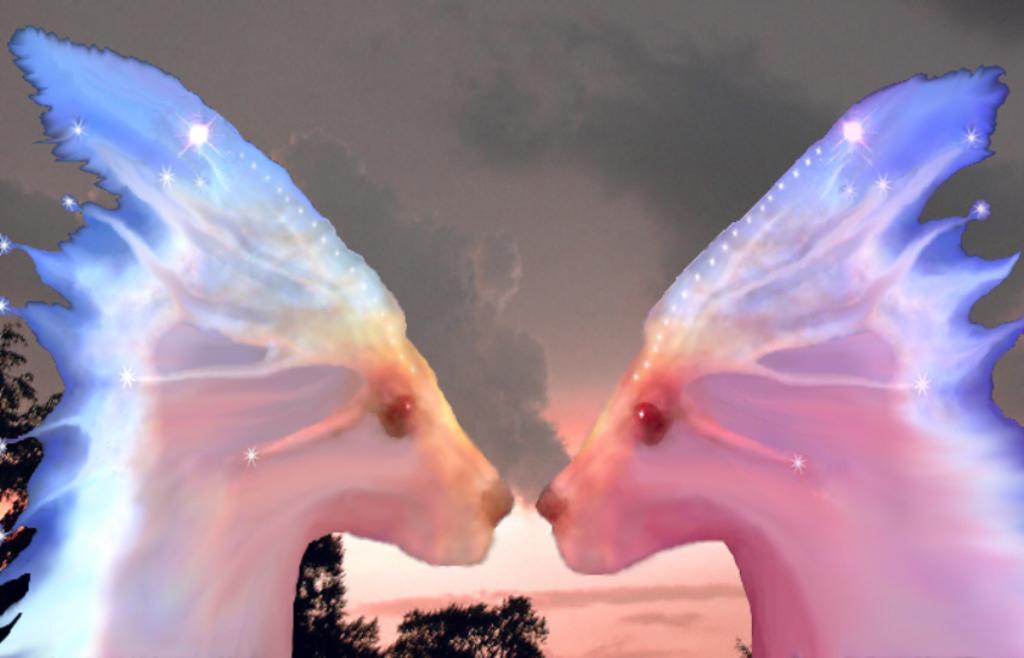Could you give a brief overview of what you see in this image? This is an edited image. In this image we can see some animals. On the backside we can see some trees and the sky which looks cloudy. 